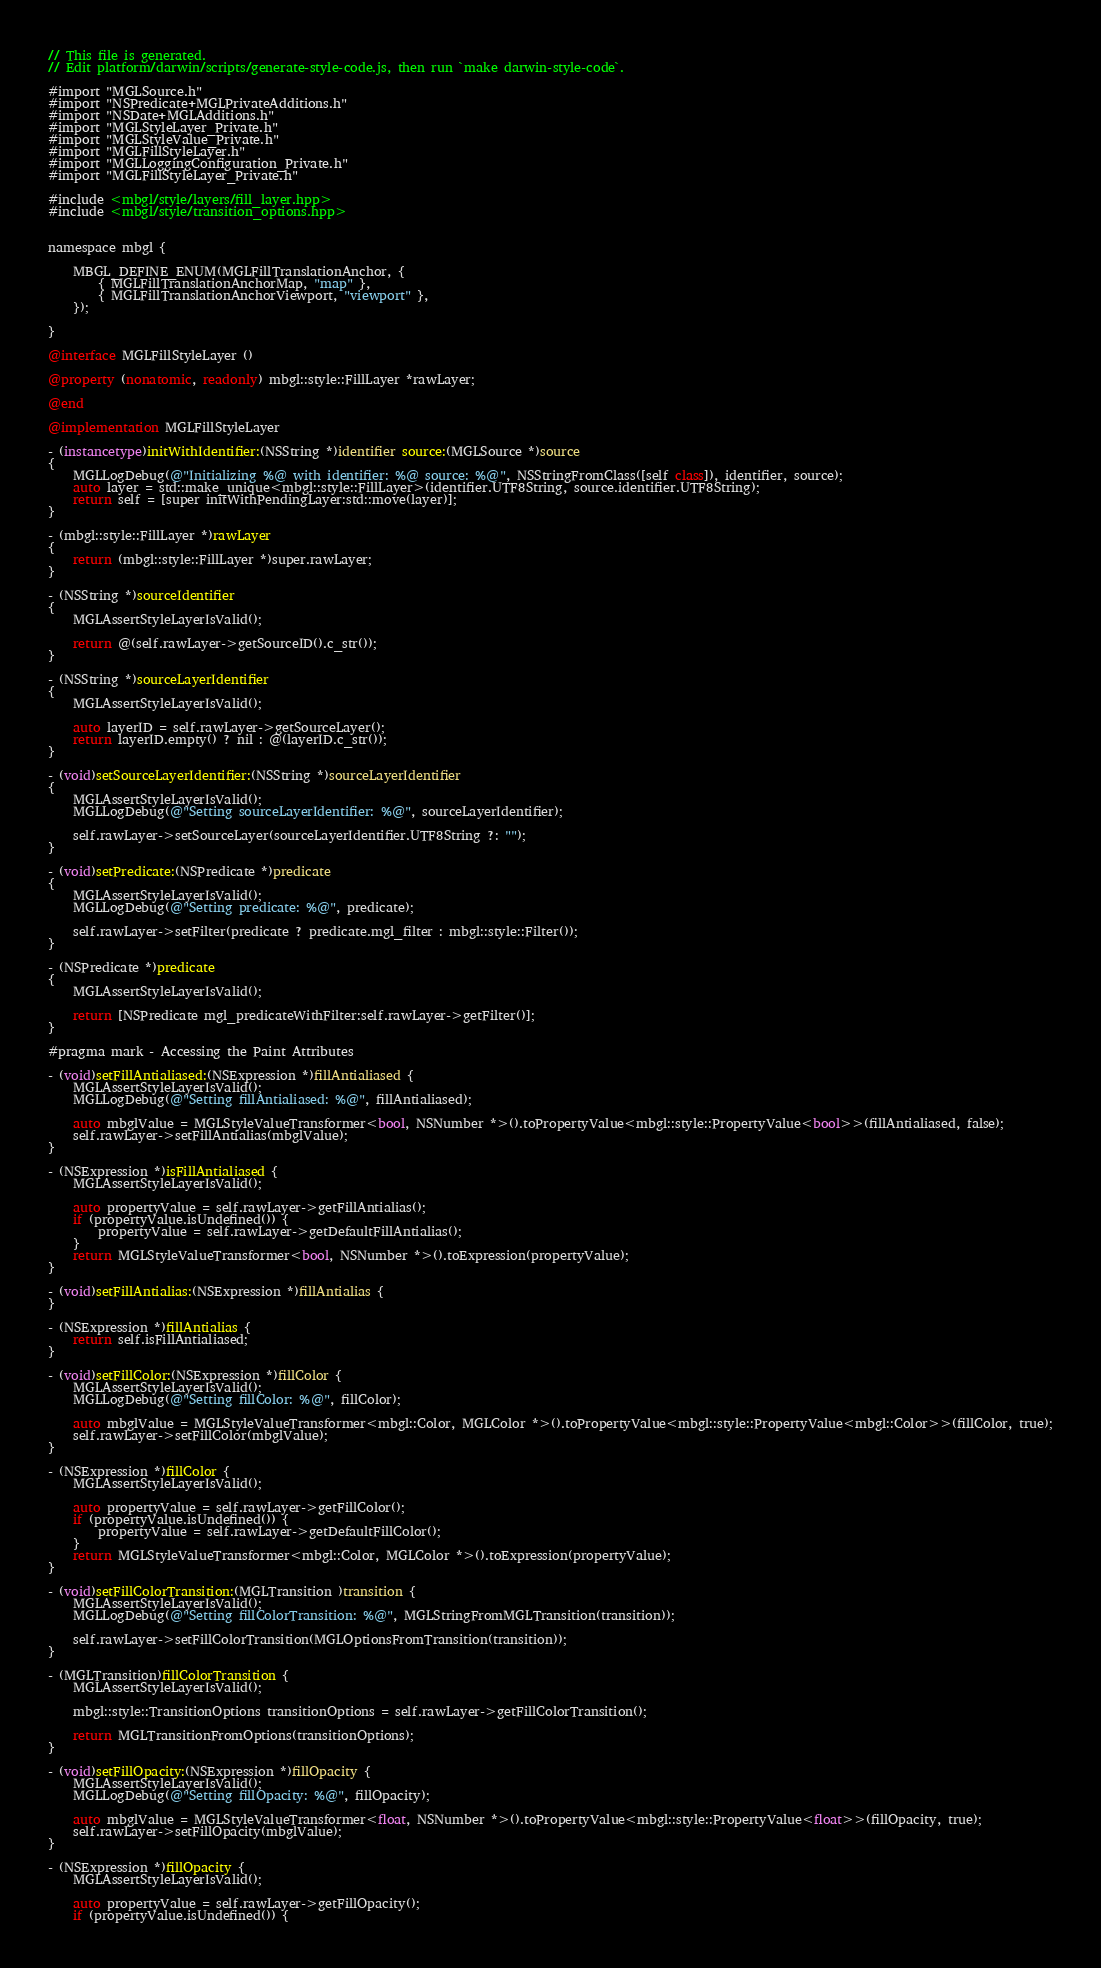Convert code to text. <code><loc_0><loc_0><loc_500><loc_500><_ObjectiveC_>// This file is generated.
// Edit platform/darwin/scripts/generate-style-code.js, then run `make darwin-style-code`.

#import "MGLSource.h"
#import "NSPredicate+MGLPrivateAdditions.h"
#import "NSDate+MGLAdditions.h"
#import "MGLStyleLayer_Private.h"
#import "MGLStyleValue_Private.h"
#import "MGLFillStyleLayer.h"
#import "MGLLoggingConfiguration_Private.h"
#import "MGLFillStyleLayer_Private.h"

#include <mbgl/style/layers/fill_layer.hpp>
#include <mbgl/style/transition_options.hpp>


namespace mbgl {

    MBGL_DEFINE_ENUM(MGLFillTranslationAnchor, {
        { MGLFillTranslationAnchorMap, "map" },
        { MGLFillTranslationAnchorViewport, "viewport" },
    });

}

@interface MGLFillStyleLayer ()

@property (nonatomic, readonly) mbgl::style::FillLayer *rawLayer;

@end

@implementation MGLFillStyleLayer

- (instancetype)initWithIdentifier:(NSString *)identifier source:(MGLSource *)source
{
    MGLLogDebug(@"Initializing %@ with identifier: %@ source: %@", NSStringFromClass([self class]), identifier, source);
    auto layer = std::make_unique<mbgl::style::FillLayer>(identifier.UTF8String, source.identifier.UTF8String);
    return self = [super initWithPendingLayer:std::move(layer)];
}

- (mbgl::style::FillLayer *)rawLayer
{
    return (mbgl::style::FillLayer *)super.rawLayer;
}

- (NSString *)sourceIdentifier
{
    MGLAssertStyleLayerIsValid();

    return @(self.rawLayer->getSourceID().c_str());
}

- (NSString *)sourceLayerIdentifier
{
    MGLAssertStyleLayerIsValid();

    auto layerID = self.rawLayer->getSourceLayer();
    return layerID.empty() ? nil : @(layerID.c_str());
}

- (void)setSourceLayerIdentifier:(NSString *)sourceLayerIdentifier
{
    MGLAssertStyleLayerIsValid();
    MGLLogDebug(@"Setting sourceLayerIdentifier: %@", sourceLayerIdentifier);

    self.rawLayer->setSourceLayer(sourceLayerIdentifier.UTF8String ?: "");
}

- (void)setPredicate:(NSPredicate *)predicate
{
    MGLAssertStyleLayerIsValid();
    MGLLogDebug(@"Setting predicate: %@", predicate);

    self.rawLayer->setFilter(predicate ? predicate.mgl_filter : mbgl::style::Filter());
}

- (NSPredicate *)predicate
{
    MGLAssertStyleLayerIsValid();

    return [NSPredicate mgl_predicateWithFilter:self.rawLayer->getFilter()];
}

#pragma mark - Accessing the Paint Attributes

- (void)setFillAntialiased:(NSExpression *)fillAntialiased {
    MGLAssertStyleLayerIsValid();
    MGLLogDebug(@"Setting fillAntialiased: %@", fillAntialiased);

    auto mbglValue = MGLStyleValueTransformer<bool, NSNumber *>().toPropertyValue<mbgl::style::PropertyValue<bool>>(fillAntialiased, false);
    self.rawLayer->setFillAntialias(mbglValue);
}

- (NSExpression *)isFillAntialiased {
    MGLAssertStyleLayerIsValid();

    auto propertyValue = self.rawLayer->getFillAntialias();
    if (propertyValue.isUndefined()) {
        propertyValue = self.rawLayer->getDefaultFillAntialias();
    }
    return MGLStyleValueTransformer<bool, NSNumber *>().toExpression(propertyValue);
}

- (void)setFillAntialias:(NSExpression *)fillAntialias {
}

- (NSExpression *)fillAntialias {
    return self.isFillAntialiased;
}

- (void)setFillColor:(NSExpression *)fillColor {
    MGLAssertStyleLayerIsValid();
    MGLLogDebug(@"Setting fillColor: %@", fillColor);

    auto mbglValue = MGLStyleValueTransformer<mbgl::Color, MGLColor *>().toPropertyValue<mbgl::style::PropertyValue<mbgl::Color>>(fillColor, true);
    self.rawLayer->setFillColor(mbglValue);
}

- (NSExpression *)fillColor {
    MGLAssertStyleLayerIsValid();

    auto propertyValue = self.rawLayer->getFillColor();
    if (propertyValue.isUndefined()) {
        propertyValue = self.rawLayer->getDefaultFillColor();
    }
    return MGLStyleValueTransformer<mbgl::Color, MGLColor *>().toExpression(propertyValue);
}

- (void)setFillColorTransition:(MGLTransition )transition {
    MGLAssertStyleLayerIsValid();
    MGLLogDebug(@"Setting fillColorTransition: %@", MGLStringFromMGLTransition(transition));

    self.rawLayer->setFillColorTransition(MGLOptionsFromTransition(transition));
}

- (MGLTransition)fillColorTransition {
    MGLAssertStyleLayerIsValid();

    mbgl::style::TransitionOptions transitionOptions = self.rawLayer->getFillColorTransition();

    return MGLTransitionFromOptions(transitionOptions);
}

- (void)setFillOpacity:(NSExpression *)fillOpacity {
    MGLAssertStyleLayerIsValid();
    MGLLogDebug(@"Setting fillOpacity: %@", fillOpacity);

    auto mbglValue = MGLStyleValueTransformer<float, NSNumber *>().toPropertyValue<mbgl::style::PropertyValue<float>>(fillOpacity, true);
    self.rawLayer->setFillOpacity(mbglValue);
}

- (NSExpression *)fillOpacity {
    MGLAssertStyleLayerIsValid();

    auto propertyValue = self.rawLayer->getFillOpacity();
    if (propertyValue.isUndefined()) {</code> 